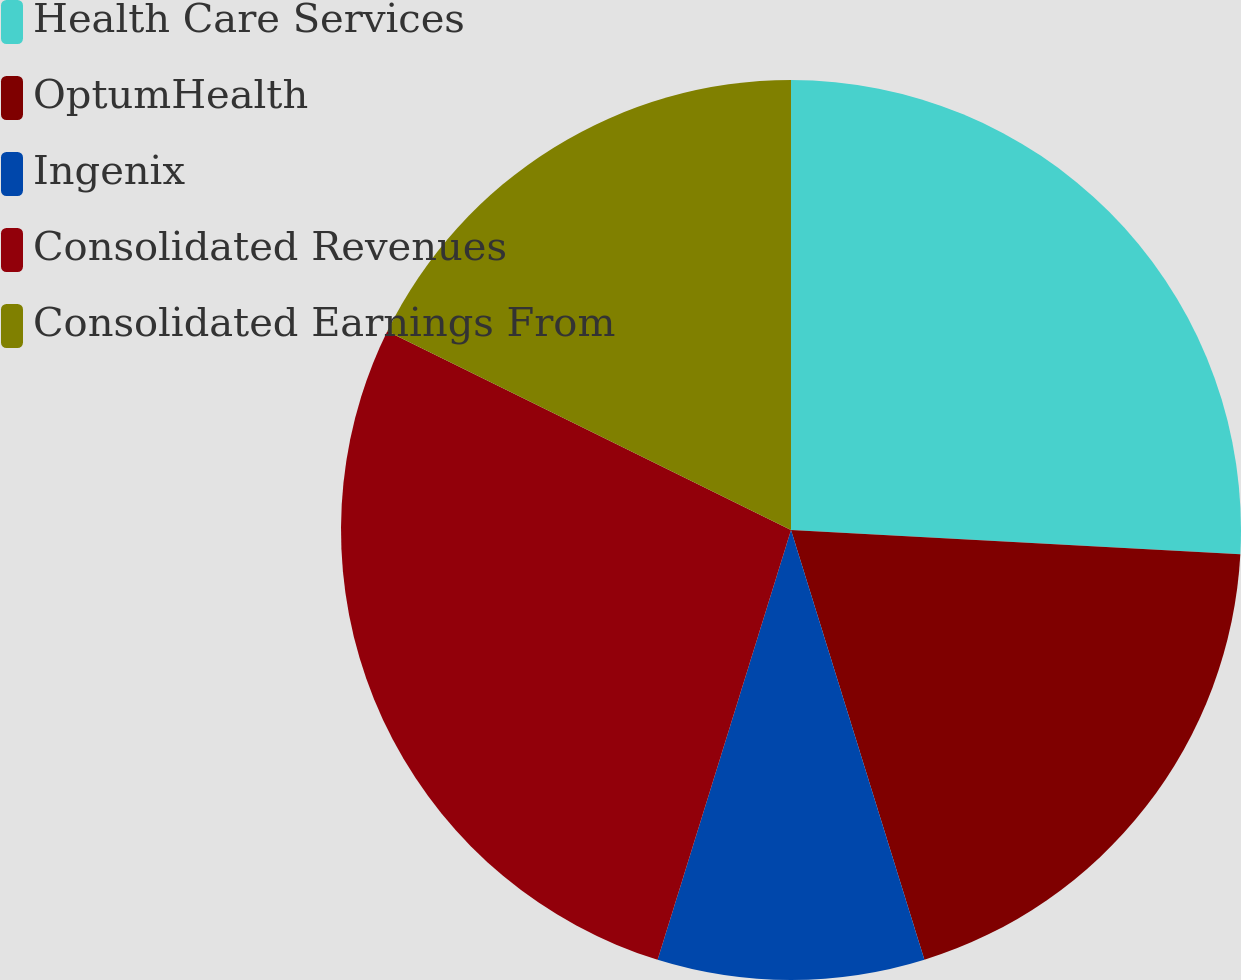<chart> <loc_0><loc_0><loc_500><loc_500><pie_chart><fcel>Health Care Services<fcel>OptumHealth<fcel>Ingenix<fcel>Consolidated Revenues<fcel>Consolidated Earnings From<nl><fcel>25.86%<fcel>19.35%<fcel>9.58%<fcel>27.49%<fcel>17.72%<nl></chart> 